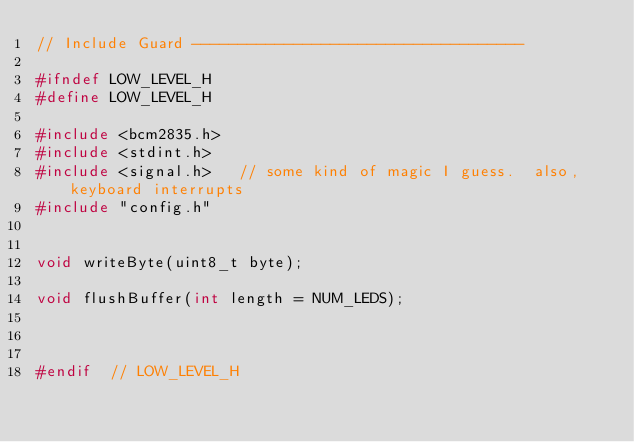Convert code to text. <code><loc_0><loc_0><loc_500><loc_500><_C_>// Include Guard ------------------------------------

#ifndef LOW_LEVEL_H
#define LOW_LEVEL_H

#include <bcm2835.h>
#include <stdint.h>
#include <signal.h>   // some kind of magic I guess.  also, keyboard interrupts
#include "config.h"


void writeByte(uint8_t byte);

void flushBuffer(int length = NUM_LEDS);



#endif  // LOW_LEVEL_H
</code> 